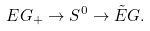<formula> <loc_0><loc_0><loc_500><loc_500>E G _ { + } \to S ^ { 0 } \to \tilde { E } G .</formula> 